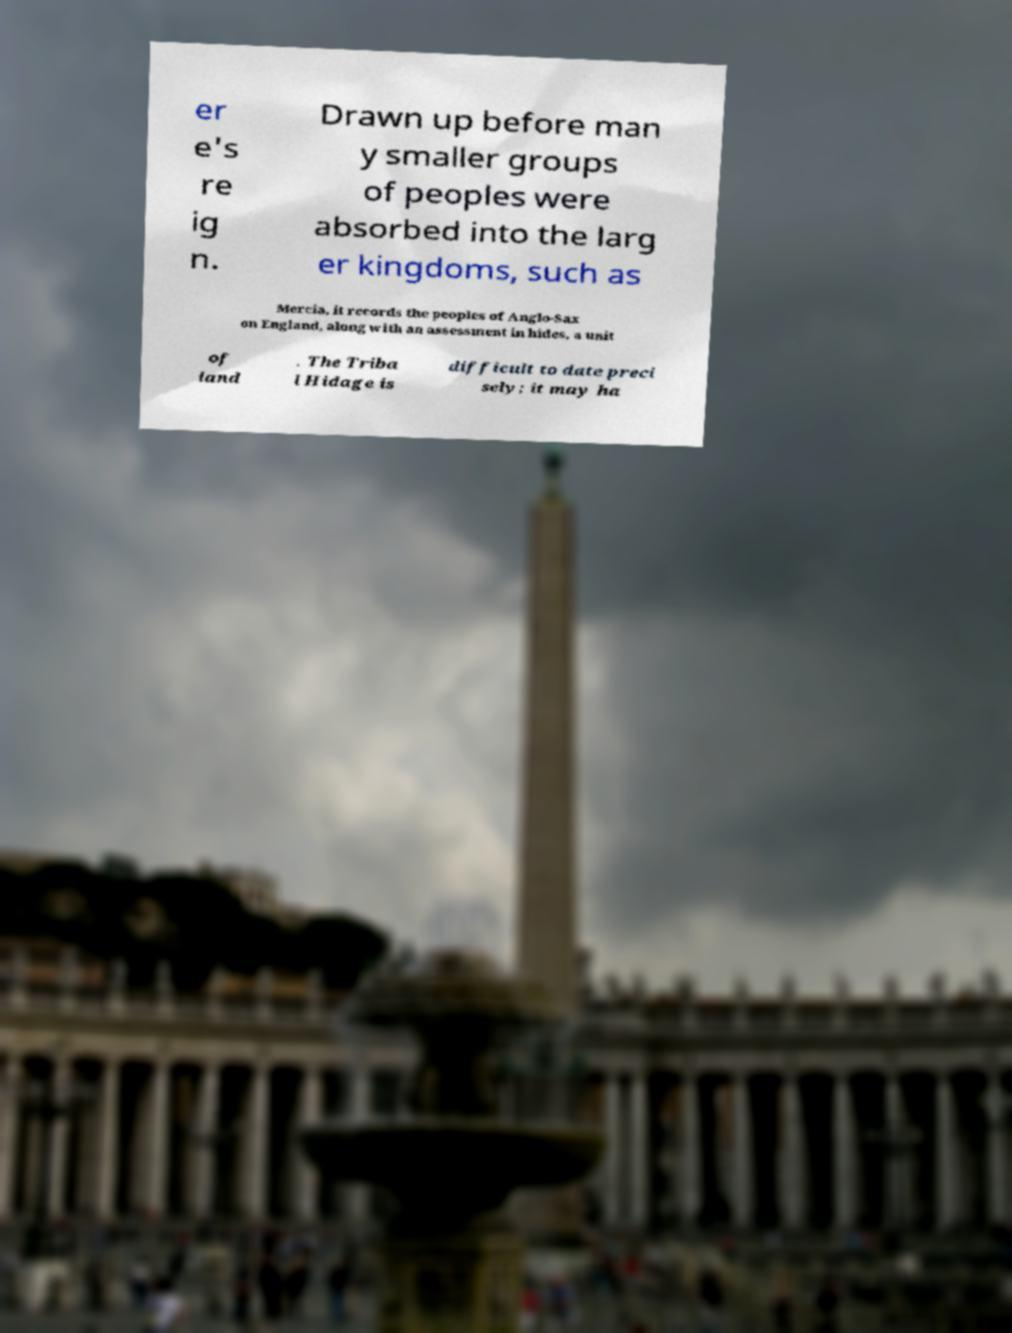I need the written content from this picture converted into text. Can you do that? er e's re ig n. Drawn up before man y smaller groups of peoples were absorbed into the larg er kingdoms, such as Mercia, it records the peoples of Anglo-Sax on England, along with an assessment in hides, a unit of land . The Triba l Hidage is difficult to date preci sely; it may ha 